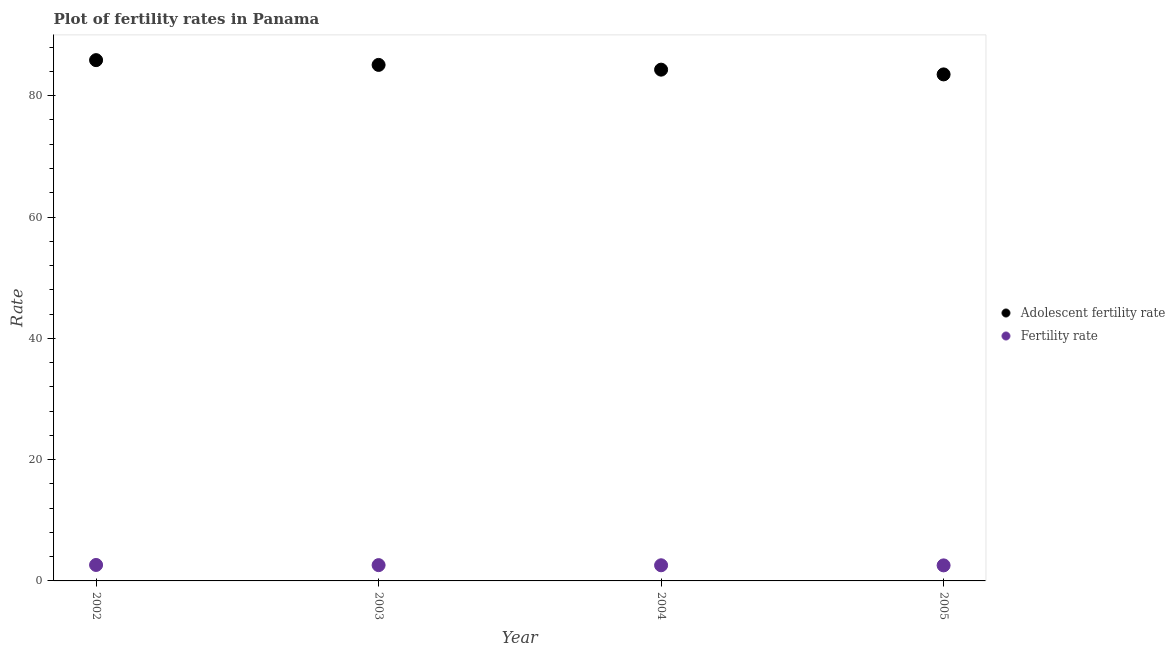Is the number of dotlines equal to the number of legend labels?
Your answer should be compact. Yes. What is the fertility rate in 2005?
Your answer should be very brief. 2.56. Across all years, what is the maximum fertility rate?
Your answer should be compact. 2.63. Across all years, what is the minimum fertility rate?
Ensure brevity in your answer.  2.56. What is the total fertility rate in the graph?
Your answer should be very brief. 10.38. What is the difference between the adolescent fertility rate in 2004 and that in 2005?
Your answer should be compact. 0.78. What is the difference between the adolescent fertility rate in 2003 and the fertility rate in 2002?
Your answer should be very brief. 82.45. What is the average fertility rate per year?
Your response must be concise. 2.59. In the year 2004, what is the difference between the adolescent fertility rate and fertility rate?
Your response must be concise. 81.72. In how many years, is the adolescent fertility rate greater than 20?
Keep it short and to the point. 4. What is the ratio of the fertility rate in 2004 to that in 2005?
Offer a terse response. 1.01. Is the difference between the adolescent fertility rate in 2003 and 2005 greater than the difference between the fertility rate in 2003 and 2005?
Your response must be concise. Yes. What is the difference between the highest and the second highest fertility rate?
Keep it short and to the point. 0.03. What is the difference between the highest and the lowest fertility rate?
Your response must be concise. 0.07. In how many years, is the adolescent fertility rate greater than the average adolescent fertility rate taken over all years?
Make the answer very short. 2. How many dotlines are there?
Keep it short and to the point. 2. What is the difference between two consecutive major ticks on the Y-axis?
Your response must be concise. 20. Are the values on the major ticks of Y-axis written in scientific E-notation?
Make the answer very short. No. Does the graph contain any zero values?
Make the answer very short. No. How many legend labels are there?
Ensure brevity in your answer.  2. What is the title of the graph?
Your answer should be compact. Plot of fertility rates in Panama. Does "Taxes on exports" appear as one of the legend labels in the graph?
Your answer should be very brief. No. What is the label or title of the Y-axis?
Offer a very short reply. Rate. What is the Rate in Adolescent fertility rate in 2002?
Your answer should be very brief. 85.87. What is the Rate in Fertility rate in 2002?
Offer a terse response. 2.63. What is the Rate of Adolescent fertility rate in 2003?
Ensure brevity in your answer.  85.09. What is the Rate of Fertility rate in 2003?
Offer a terse response. 2.6. What is the Rate in Adolescent fertility rate in 2004?
Provide a short and direct response. 84.3. What is the Rate in Fertility rate in 2004?
Ensure brevity in your answer.  2.58. What is the Rate in Adolescent fertility rate in 2005?
Ensure brevity in your answer.  83.52. What is the Rate in Fertility rate in 2005?
Provide a short and direct response. 2.56. Across all years, what is the maximum Rate in Adolescent fertility rate?
Ensure brevity in your answer.  85.87. Across all years, what is the maximum Rate of Fertility rate?
Ensure brevity in your answer.  2.63. Across all years, what is the minimum Rate of Adolescent fertility rate?
Provide a short and direct response. 83.52. Across all years, what is the minimum Rate in Fertility rate?
Your answer should be very brief. 2.56. What is the total Rate in Adolescent fertility rate in the graph?
Ensure brevity in your answer.  338.77. What is the total Rate of Fertility rate in the graph?
Give a very brief answer. 10.38. What is the difference between the Rate of Adolescent fertility rate in 2002 and that in 2003?
Ensure brevity in your answer.  0.78. What is the difference between the Rate in Fertility rate in 2002 and that in 2003?
Ensure brevity in your answer.  0.03. What is the difference between the Rate of Adolescent fertility rate in 2002 and that in 2004?
Give a very brief answer. 1.57. What is the difference between the Rate of Fertility rate in 2002 and that in 2004?
Your answer should be compact. 0.05. What is the difference between the Rate in Adolescent fertility rate in 2002 and that in 2005?
Provide a short and direct response. 2.35. What is the difference between the Rate of Fertility rate in 2002 and that in 2005?
Give a very brief answer. 0.07. What is the difference between the Rate in Adolescent fertility rate in 2003 and that in 2004?
Keep it short and to the point. 0.78. What is the difference between the Rate in Fertility rate in 2003 and that in 2004?
Offer a very short reply. 0.02. What is the difference between the Rate of Adolescent fertility rate in 2003 and that in 2005?
Keep it short and to the point. 1.57. What is the difference between the Rate of Fertility rate in 2003 and that in 2005?
Provide a succinct answer. 0.04. What is the difference between the Rate of Adolescent fertility rate in 2004 and that in 2005?
Provide a succinct answer. 0.78. What is the difference between the Rate in Fertility rate in 2004 and that in 2005?
Provide a succinct answer. 0.02. What is the difference between the Rate of Adolescent fertility rate in 2002 and the Rate of Fertility rate in 2003?
Your response must be concise. 83.27. What is the difference between the Rate in Adolescent fertility rate in 2002 and the Rate in Fertility rate in 2004?
Ensure brevity in your answer.  83.29. What is the difference between the Rate in Adolescent fertility rate in 2002 and the Rate in Fertility rate in 2005?
Give a very brief answer. 83.31. What is the difference between the Rate in Adolescent fertility rate in 2003 and the Rate in Fertility rate in 2004?
Keep it short and to the point. 82.51. What is the difference between the Rate of Adolescent fertility rate in 2003 and the Rate of Fertility rate in 2005?
Ensure brevity in your answer.  82.52. What is the difference between the Rate in Adolescent fertility rate in 2004 and the Rate in Fertility rate in 2005?
Make the answer very short. 81.74. What is the average Rate in Adolescent fertility rate per year?
Your response must be concise. 84.69. What is the average Rate of Fertility rate per year?
Your response must be concise. 2.59. In the year 2002, what is the difference between the Rate in Adolescent fertility rate and Rate in Fertility rate?
Give a very brief answer. 83.24. In the year 2003, what is the difference between the Rate in Adolescent fertility rate and Rate in Fertility rate?
Offer a very short reply. 82.48. In the year 2004, what is the difference between the Rate of Adolescent fertility rate and Rate of Fertility rate?
Your response must be concise. 81.72. In the year 2005, what is the difference between the Rate of Adolescent fertility rate and Rate of Fertility rate?
Give a very brief answer. 80.96. What is the ratio of the Rate in Adolescent fertility rate in 2002 to that in 2003?
Your answer should be compact. 1.01. What is the ratio of the Rate of Fertility rate in 2002 to that in 2003?
Ensure brevity in your answer.  1.01. What is the ratio of the Rate of Adolescent fertility rate in 2002 to that in 2004?
Provide a short and direct response. 1.02. What is the ratio of the Rate in Fertility rate in 2002 to that in 2004?
Provide a short and direct response. 1.02. What is the ratio of the Rate of Adolescent fertility rate in 2002 to that in 2005?
Your response must be concise. 1.03. What is the ratio of the Rate of Fertility rate in 2002 to that in 2005?
Offer a very short reply. 1.03. What is the ratio of the Rate of Adolescent fertility rate in 2003 to that in 2004?
Your response must be concise. 1.01. What is the ratio of the Rate in Fertility rate in 2003 to that in 2004?
Keep it short and to the point. 1.01. What is the ratio of the Rate of Adolescent fertility rate in 2003 to that in 2005?
Your response must be concise. 1.02. What is the ratio of the Rate in Fertility rate in 2003 to that in 2005?
Give a very brief answer. 1.02. What is the ratio of the Rate in Adolescent fertility rate in 2004 to that in 2005?
Your answer should be very brief. 1.01. What is the ratio of the Rate of Fertility rate in 2004 to that in 2005?
Give a very brief answer. 1.01. What is the difference between the highest and the second highest Rate of Adolescent fertility rate?
Offer a very short reply. 0.78. What is the difference between the highest and the second highest Rate of Fertility rate?
Keep it short and to the point. 0.03. What is the difference between the highest and the lowest Rate in Adolescent fertility rate?
Give a very brief answer. 2.35. What is the difference between the highest and the lowest Rate in Fertility rate?
Offer a terse response. 0.07. 